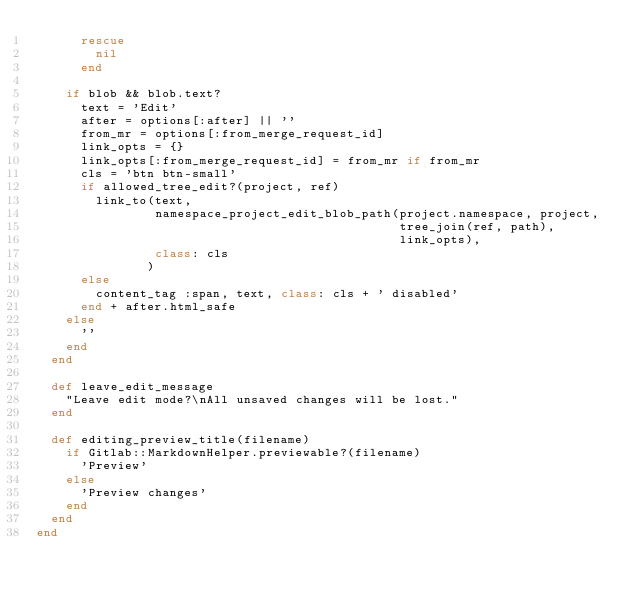<code> <loc_0><loc_0><loc_500><loc_500><_Ruby_>      rescue
        nil
      end

    if blob && blob.text?
      text = 'Edit'
      after = options[:after] || ''
      from_mr = options[:from_merge_request_id]
      link_opts = {}
      link_opts[:from_merge_request_id] = from_mr if from_mr
      cls = 'btn btn-small'
      if allowed_tree_edit?(project, ref)
        link_to(text,
                namespace_project_edit_blob_path(project.namespace, project,
                                                 tree_join(ref, path),
                                                 link_opts),
                class: cls
               )
      else
        content_tag :span, text, class: cls + ' disabled'
      end + after.html_safe
    else
      ''
    end
  end

  def leave_edit_message
    "Leave edit mode?\nAll unsaved changes will be lost."
  end

  def editing_preview_title(filename)
    if Gitlab::MarkdownHelper.previewable?(filename)
      'Preview'
    else
      'Preview changes'
    end
  end
end
</code> 